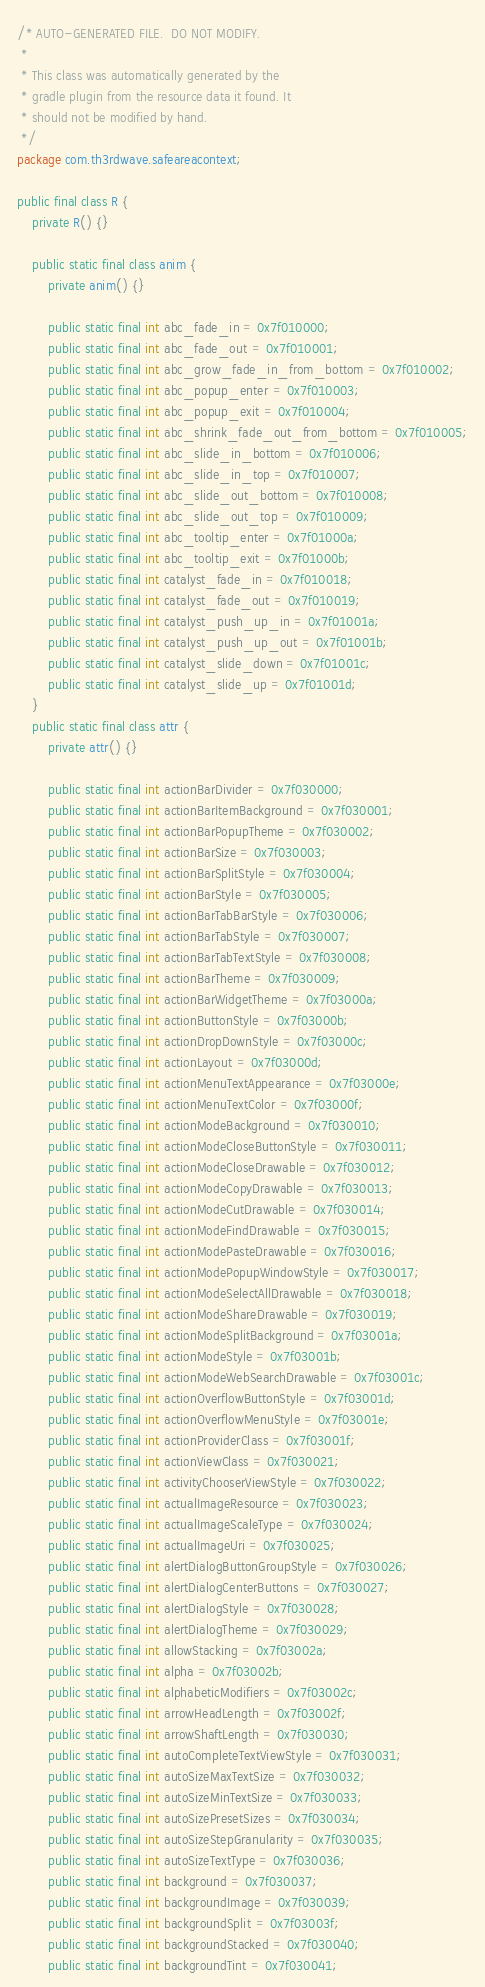Convert code to text. <code><loc_0><loc_0><loc_500><loc_500><_Java_>/* AUTO-GENERATED FILE.  DO NOT MODIFY.
 *
 * This class was automatically generated by the
 * gradle plugin from the resource data it found. It
 * should not be modified by hand.
 */
package com.th3rdwave.safeareacontext;

public final class R {
    private R() {}

    public static final class anim {
        private anim() {}

        public static final int abc_fade_in = 0x7f010000;
        public static final int abc_fade_out = 0x7f010001;
        public static final int abc_grow_fade_in_from_bottom = 0x7f010002;
        public static final int abc_popup_enter = 0x7f010003;
        public static final int abc_popup_exit = 0x7f010004;
        public static final int abc_shrink_fade_out_from_bottom = 0x7f010005;
        public static final int abc_slide_in_bottom = 0x7f010006;
        public static final int abc_slide_in_top = 0x7f010007;
        public static final int abc_slide_out_bottom = 0x7f010008;
        public static final int abc_slide_out_top = 0x7f010009;
        public static final int abc_tooltip_enter = 0x7f01000a;
        public static final int abc_tooltip_exit = 0x7f01000b;
        public static final int catalyst_fade_in = 0x7f010018;
        public static final int catalyst_fade_out = 0x7f010019;
        public static final int catalyst_push_up_in = 0x7f01001a;
        public static final int catalyst_push_up_out = 0x7f01001b;
        public static final int catalyst_slide_down = 0x7f01001c;
        public static final int catalyst_slide_up = 0x7f01001d;
    }
    public static final class attr {
        private attr() {}

        public static final int actionBarDivider = 0x7f030000;
        public static final int actionBarItemBackground = 0x7f030001;
        public static final int actionBarPopupTheme = 0x7f030002;
        public static final int actionBarSize = 0x7f030003;
        public static final int actionBarSplitStyle = 0x7f030004;
        public static final int actionBarStyle = 0x7f030005;
        public static final int actionBarTabBarStyle = 0x7f030006;
        public static final int actionBarTabStyle = 0x7f030007;
        public static final int actionBarTabTextStyle = 0x7f030008;
        public static final int actionBarTheme = 0x7f030009;
        public static final int actionBarWidgetTheme = 0x7f03000a;
        public static final int actionButtonStyle = 0x7f03000b;
        public static final int actionDropDownStyle = 0x7f03000c;
        public static final int actionLayout = 0x7f03000d;
        public static final int actionMenuTextAppearance = 0x7f03000e;
        public static final int actionMenuTextColor = 0x7f03000f;
        public static final int actionModeBackground = 0x7f030010;
        public static final int actionModeCloseButtonStyle = 0x7f030011;
        public static final int actionModeCloseDrawable = 0x7f030012;
        public static final int actionModeCopyDrawable = 0x7f030013;
        public static final int actionModeCutDrawable = 0x7f030014;
        public static final int actionModeFindDrawable = 0x7f030015;
        public static final int actionModePasteDrawable = 0x7f030016;
        public static final int actionModePopupWindowStyle = 0x7f030017;
        public static final int actionModeSelectAllDrawable = 0x7f030018;
        public static final int actionModeShareDrawable = 0x7f030019;
        public static final int actionModeSplitBackground = 0x7f03001a;
        public static final int actionModeStyle = 0x7f03001b;
        public static final int actionModeWebSearchDrawable = 0x7f03001c;
        public static final int actionOverflowButtonStyle = 0x7f03001d;
        public static final int actionOverflowMenuStyle = 0x7f03001e;
        public static final int actionProviderClass = 0x7f03001f;
        public static final int actionViewClass = 0x7f030021;
        public static final int activityChooserViewStyle = 0x7f030022;
        public static final int actualImageResource = 0x7f030023;
        public static final int actualImageScaleType = 0x7f030024;
        public static final int actualImageUri = 0x7f030025;
        public static final int alertDialogButtonGroupStyle = 0x7f030026;
        public static final int alertDialogCenterButtons = 0x7f030027;
        public static final int alertDialogStyle = 0x7f030028;
        public static final int alertDialogTheme = 0x7f030029;
        public static final int allowStacking = 0x7f03002a;
        public static final int alpha = 0x7f03002b;
        public static final int alphabeticModifiers = 0x7f03002c;
        public static final int arrowHeadLength = 0x7f03002f;
        public static final int arrowShaftLength = 0x7f030030;
        public static final int autoCompleteTextViewStyle = 0x7f030031;
        public static final int autoSizeMaxTextSize = 0x7f030032;
        public static final int autoSizeMinTextSize = 0x7f030033;
        public static final int autoSizePresetSizes = 0x7f030034;
        public static final int autoSizeStepGranularity = 0x7f030035;
        public static final int autoSizeTextType = 0x7f030036;
        public static final int background = 0x7f030037;
        public static final int backgroundImage = 0x7f030039;
        public static final int backgroundSplit = 0x7f03003f;
        public static final int backgroundStacked = 0x7f030040;
        public static final int backgroundTint = 0x7f030041;</code> 